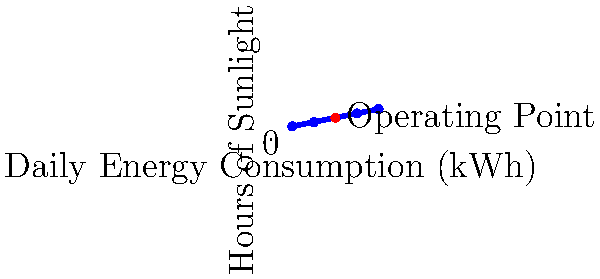For a small concession stand at a youth sports event, you need to size a solar panel system. The stand requires 15 kWh of energy per day and receives an average of 5 hours of peak sunlight. If the solar panels are 20% efficient and you want a 25% buffer for cloudy days, what is the minimum required solar panel array size in square meters? Assume 1 kW/m² of solar irradiance at peak conditions. To size the solar panel system, we'll follow these steps:

1. Calculate the daily energy requirement with buffer:
   $15 \text{ kWh} \times 1.25 = 18.75 \text{ kWh}$

2. Determine the required power output:
   $\frac{18.75 \text{ kWh}}{5 \text{ hours}} = 3.75 \text{ kW}$

3. Account for panel efficiency:
   $\frac{3.75 \text{ kW}}{0.20} = 18.75 \text{ kW}$

4. Calculate the required array size:
   $\frac{18.75 \text{ kW}}{1 \text{ kW/m²}} = 18.75 \text{ m²}$

Therefore, the minimum required solar panel array size is 18.75 square meters.
Answer: 18.75 m² 